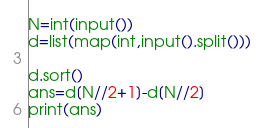Convert code to text. <code><loc_0><loc_0><loc_500><loc_500><_Python_>N=int(input())
d=list(map(int,input().split()))

d.sort()
ans=d[N//2+1]-d[N//2]
print(ans)
</code> 